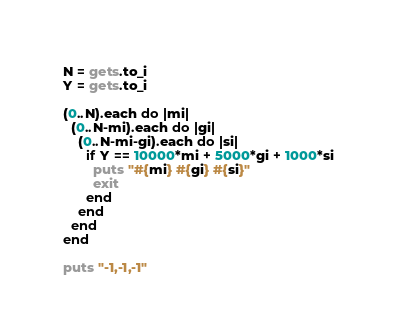<code> <loc_0><loc_0><loc_500><loc_500><_Ruby_>N = gets.to_i
Y = gets.to_i

(0..N).each do |mi|
  (0..N-mi).each do |gi|
    (0..N-mi-gi).each do |si|
      if Y == 10000*mi + 5000*gi + 1000*si
        puts "#{mi} #{gi} #{si}"
        exit
      end
    end
  end
end

puts "-1,-1,-1"
</code> 